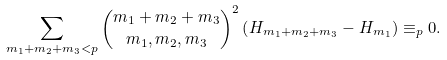Convert formula to latex. <formula><loc_0><loc_0><loc_500><loc_500>\sum _ { m _ { 1 } + m _ { 2 } + m _ { 3 } < p } \binom { m _ { 1 } + m _ { 2 } + m _ { 3 } } { m _ { 1 } , m _ { 2 } , m _ { 3 } } ^ { 2 } \left ( H _ { m _ { 1 } + m _ { 2 } + m _ { 3 } } - H _ { m _ { 1 } } \right ) \equiv _ { p } 0 .</formula> 